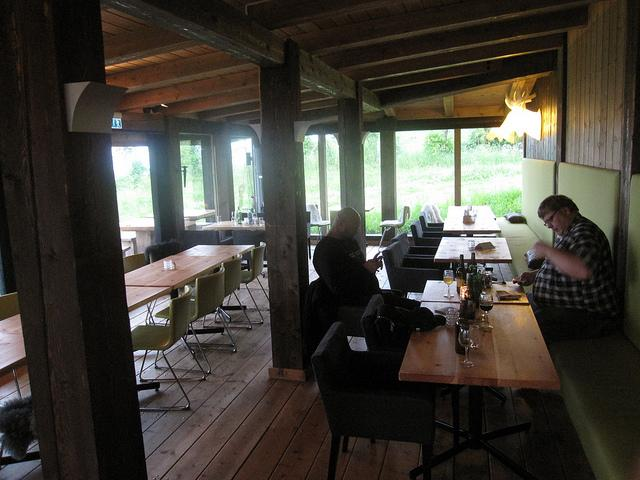What kind of shirt is the heavier man wearing? plaid 